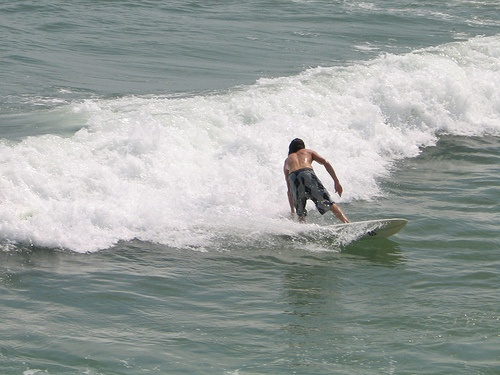Describe the objects in this image and their specific colors. I can see people in gray, black, and darkgray tones and surfboard in gray, darkgray, lightgray, and darkgreen tones in this image. 